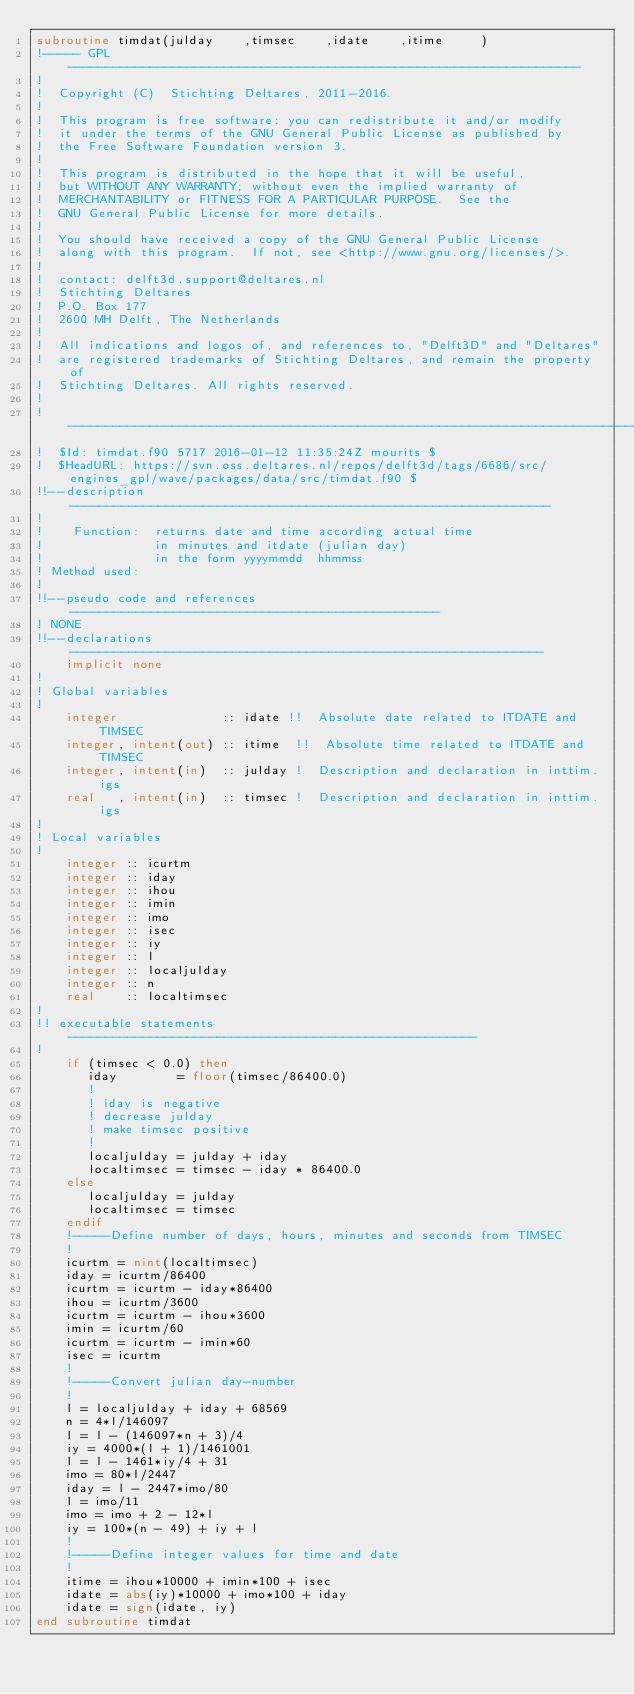Convert code to text. <code><loc_0><loc_0><loc_500><loc_500><_FORTRAN_>subroutine timdat(julday    ,timsec    ,idate    ,itime     )
!----- GPL ---------------------------------------------------------------------
!                                                                               
!  Copyright (C)  Stichting Deltares, 2011-2016.                                
!                                                                               
!  This program is free software: you can redistribute it and/or modify         
!  it under the terms of the GNU General Public License as published by         
!  the Free Software Foundation version 3.                                      
!                                                                               
!  This program is distributed in the hope that it will be useful,              
!  but WITHOUT ANY WARRANTY; without even the implied warranty of               
!  MERCHANTABILITY or FITNESS FOR A PARTICULAR PURPOSE.  See the                
!  GNU General Public License for more details.                                 
!                                                                               
!  You should have received a copy of the GNU General Public License            
!  along with this program.  If not, see <http://www.gnu.org/licenses/>.        
!                                                                               
!  contact: delft3d.support@deltares.nl                                         
!  Stichting Deltares                                                           
!  P.O. Box 177                                                                 
!  2600 MH Delft, The Netherlands                                               
!                                                                               
!  All indications and logos of, and references to, "Delft3D" and "Deltares"    
!  are registered trademarks of Stichting Deltares, and remain the property of  
!  Stichting Deltares. All rights reserved.                                     
!                                                                               
!-------------------------------------------------------------------------------
!  $Id: timdat.f90 5717 2016-01-12 11:35:24Z mourits $
!  $HeadURL: https://svn.oss.deltares.nl/repos/delft3d/tags/6686/src/engines_gpl/wave/packages/data/src/timdat.f90 $
!!--description-----------------------------------------------------------------
!
!    Function:  returns date and time according actual time
!               in minutes and itdate (julian day)
!               in the form yyyymmdd  hhmmss
! Method used:
!
!!--pseudo code and references--------------------------------------------------
! NONE
!!--declarations----------------------------------------------------------------
    implicit none
!
! Global variables
!
    integer              :: idate !!  Absolute date related to ITDATE and TIMSEC
    integer, intent(out) :: itime  !!  Absolute time related to ITDATE and TIMSEC
    integer, intent(in)  :: julday !  Description and declaration in inttim.igs
    real   , intent(in)  :: timsec !  Description and declaration in inttim.igs
!
! Local variables
!
    integer :: icurtm
    integer :: iday
    integer :: ihou
    integer :: imin
    integer :: imo
    integer :: isec
    integer :: iy
    integer :: l
    integer :: localjulday
    integer :: n
    real    :: localtimsec
!
!! executable statements -------------------------------------------------------
!
    if (timsec < 0.0) then
       iday        = floor(timsec/86400.0)
       !
       ! iday is negative
       ! decrease julday
       ! make timsec positive
       !
       localjulday = julday + iday
       localtimsec = timsec - iday * 86400.0
    else
       localjulday = julday
       localtimsec = timsec
    endif
    !-----Define number of days, hours, minutes and seconds from TIMSEC
    !
    icurtm = nint(localtimsec)
    iday = icurtm/86400
    icurtm = icurtm - iday*86400
    ihou = icurtm/3600
    icurtm = icurtm - ihou*3600
    imin = icurtm/60
    icurtm = icurtm - imin*60
    isec = icurtm
    !
    !-----Convert julian day-number
    !
    l = localjulday + iday + 68569
    n = 4*l/146097
    l = l - (146097*n + 3)/4
    iy = 4000*(l + 1)/1461001
    l = l - 1461*iy/4 + 31
    imo = 80*l/2447
    iday = l - 2447*imo/80
    l = imo/11
    imo = imo + 2 - 12*l
    iy = 100*(n - 49) + iy + l
    !
    !-----Define integer values for time and date
    !
    itime = ihou*10000 + imin*100 + isec
    idate = abs(iy)*10000 + imo*100 + iday
    idate = sign(idate, iy)
end subroutine timdat
</code> 